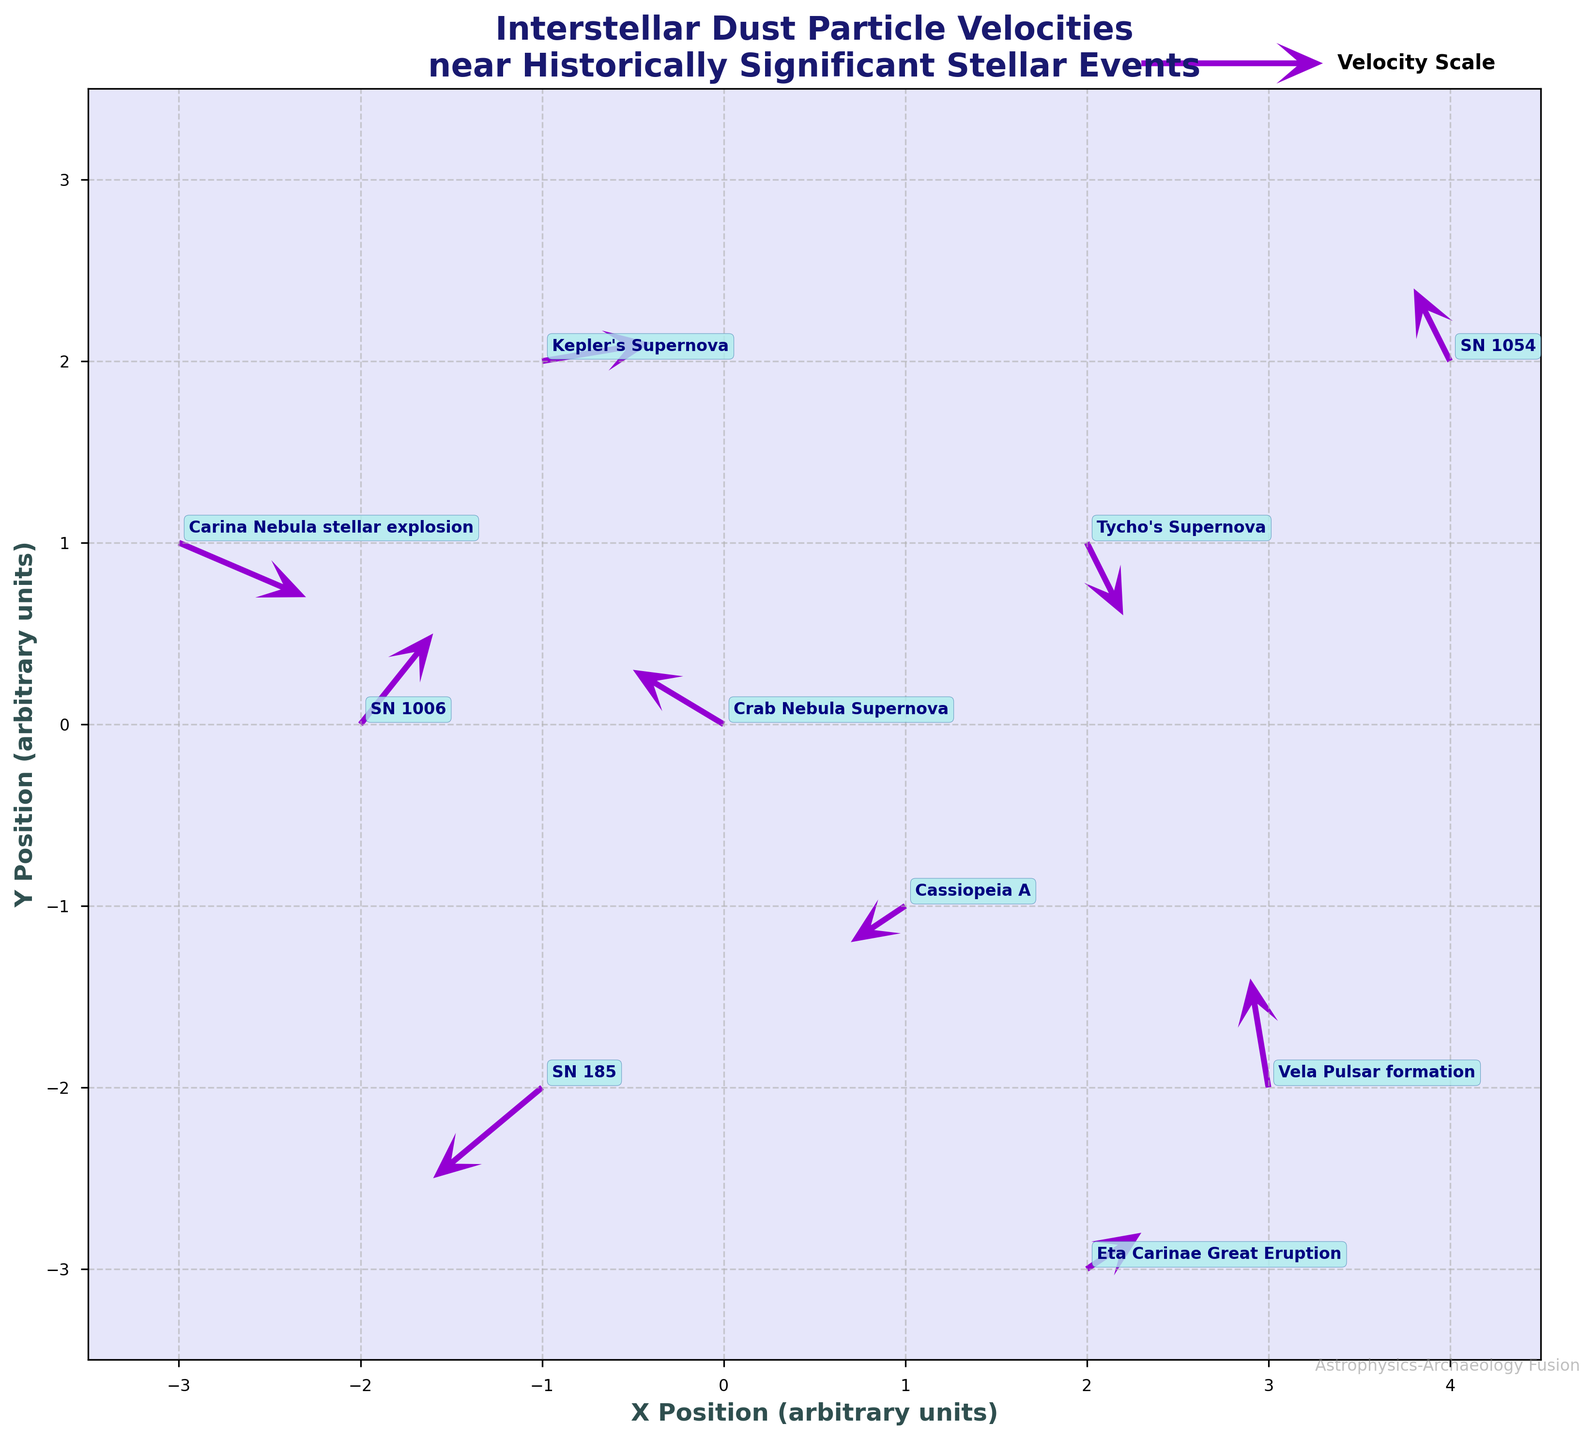question: What is the title of the plot? explanation: The title is displayed at the top center of the plot using a bold font for emphasis.
Answer: Interstellar Dust Particle Velocities near Historically Significant Stellar Events question: What is the color of the arrows in the quiver plot? explanation: The color of the arrows is clearly visible in the plot, and it is also mentioned in the code as 'darkviolet'.
Answer: darkviolet question: How many historical stellar events are labeled in the plot? explanation: Each historical stellar event corresponds to a data point with a label. There are 10 unique data points, each with its label visible.
Answer: 10 question: What is the direction and magnitude of the velocity vector at (2, 1) associated with Tycho's Supernova? explanation: The velocity vector at (2, 1) for Tycho's Supernova has components u=0.2 and v=-0.4. The magnitude can be found using the formula sqrt(u^2 + v^2).
Answer: u=0.2, v=-0.4, magnitude = sqrt(0.2^2 + (-0.4)^2) = sqrt(0.04 + 0.16) = sqrt(0.2) ≈ 0.45 question: Which stellar event has a velocity vector pointing almost directly downward? explanation: A velocity vector pointing downward would have a negative v-component and a small or zero u-component. By observing the plot or the data, Cassiopeia A at (1, -1) with u=-0.3 and v=-0.2 points downward.
Answer: Cassiopeia A question: Between Crab Nebula Supernova and Kepler's Supernova, which event shows higher velocity magnitude? explanation: Calculate the magnitude of velocity vectors for both events. For Crab Nebula Supernova at (0,0) with u=-0.5 and v=0.3: sqrt((-0.5)^2 + 0.3^2) = sqrt(0.25 + 0.09) = sqrt(0.34) ≈ 0.58. For Kepler's Supernova at (-1,2) with u=0.6 and v=0.1: sqrt(0.6^2 + 0.1^2) = sqrt(0.36 + 0.01) = sqrt(0.37) ≈ 0.61.
Answer: Kepler's Supernova question: What is the direction of the velocity vector associated with SN 1054 event? explanation: The direction of a vector can be found by observing its components u and v. For SN 1054 at (4, 2) with u=-0.2 and v=0.4, the direction can be described as towards the upper left.
Answer: upper left question: Are there any vectors in the plot that have both negative x (u) and y (v) components? If so, which historical event does it correspond to? explanation: Check the data or plot for vectors where both components are negative. The vector for SN 185 at (-1, -2) has u=-0.6 and v=-0.5.
Answer: SN 185 question: Which historical event is located at the leftmost position on the x-axis? explanation: The event with the smallest x-coordinate value in the plot is Carina Nebula stellar explosion at (-3, 1).
Answer: Carina Nebula stellarexplosion 